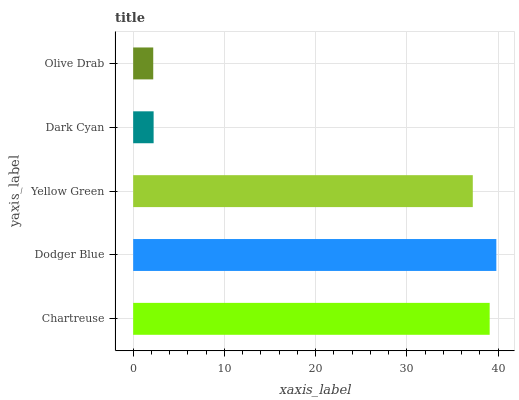Is Olive Drab the minimum?
Answer yes or no. Yes. Is Dodger Blue the maximum?
Answer yes or no. Yes. Is Yellow Green the minimum?
Answer yes or no. No. Is Yellow Green the maximum?
Answer yes or no. No. Is Dodger Blue greater than Yellow Green?
Answer yes or no. Yes. Is Yellow Green less than Dodger Blue?
Answer yes or no. Yes. Is Yellow Green greater than Dodger Blue?
Answer yes or no. No. Is Dodger Blue less than Yellow Green?
Answer yes or no. No. Is Yellow Green the high median?
Answer yes or no. Yes. Is Yellow Green the low median?
Answer yes or no. Yes. Is Dark Cyan the high median?
Answer yes or no. No. Is Dark Cyan the low median?
Answer yes or no. No. 